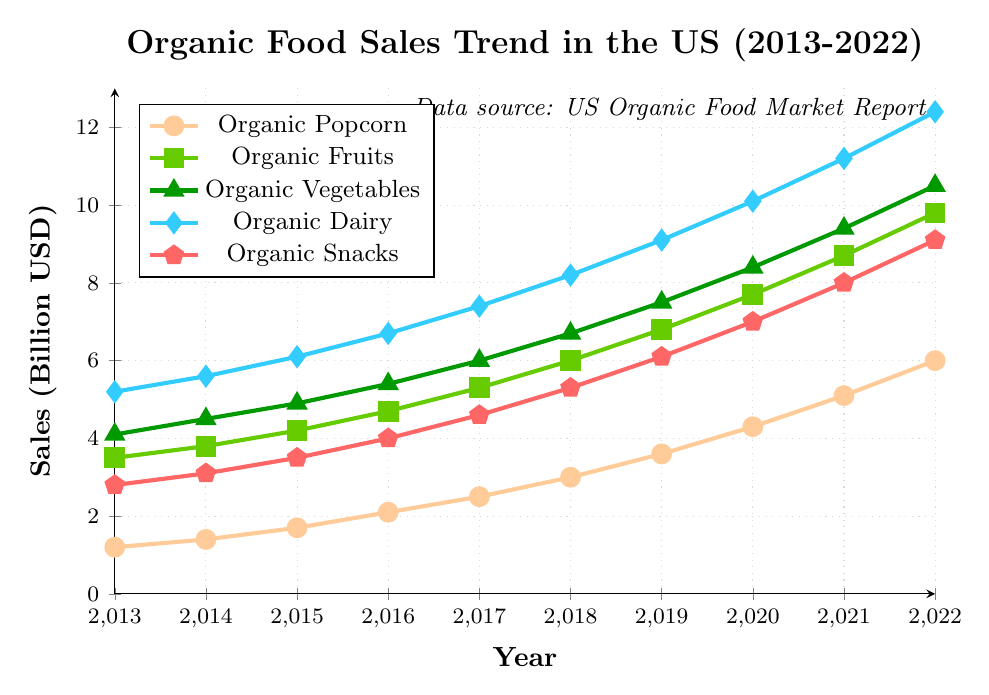What was the sales value of organic popcorn in 2016? Look at the point corresponding to 2016 in the Organic Popcorn series. The value is 2.1 billion USD.
Answer: 2.1 billion USD Which product category had the highest sales in 2022 and what was its value? Look at all the lines at the year 2022. The highest point corresponds to Organic Dairy with a value of 12.4 billion USD.
Answer: Organic Dairy, 12.4 billion USD Between 2013 and 2022, which product category showed the greatest increase in sales? Find the difference in values between 2013 and 2022 for each category:
- Organic Popcorn: 6.0 - 1.2 = 4.8
- Organic Fruits: 9.8 - 3.5 = 6.3
- Organic Vegetables: 10.5 - 4.1 = 6.4
- Organic Dairy: 12.4 - 5.2 = 7.2
- Organic Snacks: 9.1 - 2.8 = 6.3
The greatest increase is for Organic Dairy.
Answer: Organic Dairy In which year did the sales of organic fruits surpass 7 billion USD? Check the data points for Organic Fruits. Sales surpass 7 billion USD in 2019.
Answer: 2019 What is the combined sales value of organic vegetables and organic snacks in 2020? Look at the sales values for 2020:
- Organic Vegetables: 8.4
- Organic Snacks: 7.0
Add them together: 8.4 + 7.0 = 15.4 billion USD.
Answer: 15.4 billion USD Did the growth rate of organic popcorn's sales increase more between 2013-2017 or 2017-2022? Calculate the growth rates:
- 2013 to 2017: (2.5 - 1.2) / (2017 - 2013) = 1.3 / 4 = 0.325 billion USD per year
- 2017 to 2022: (6.0 - 2.5) / (2022 - 2017) = 3.5 / 5 = 0.7 billion USD per year
The growth rate was higher between 2017-2022.
Answer: 2017-2022 What was the average sales value of organic dairy products over the entire period (2013-2022)? Sum the sales values of Organic Dairy from 2013 to 2022 and divide by the number of years:
(5.2 + 5.6 + 6.1 + 6.7 + 7.4 + 8.2 + 9.1 + 10.1 + 11.2 + 12.4) / 10 = 82 / 10 = 8.2 billion USD
Answer: 8.2 billion USD How many years did it take for the sales of organic snacks to triple from their value in 2013? The sales value in 2013 for Organic Snacks was 2.8 billion USD. Tripling this gives 3 * 2.8 = 8.4 billion USD. Check years:
- Sales reached 8.4 billion USD in 2021. 
It took 2021 - 2013 = 8 years.
Answer: 8 years Is there any product category where sales never decreased from one year to the next? Check each category's sales values over the years:
- Organic Popcorn: Always increased
- Organic Fruits: Always increased
- Organic Vegetables: Always increased
- Organic Dairy: Always increased
- Organic Snacks: Always increased
All categories had consistent increases.
Answer: All categories 